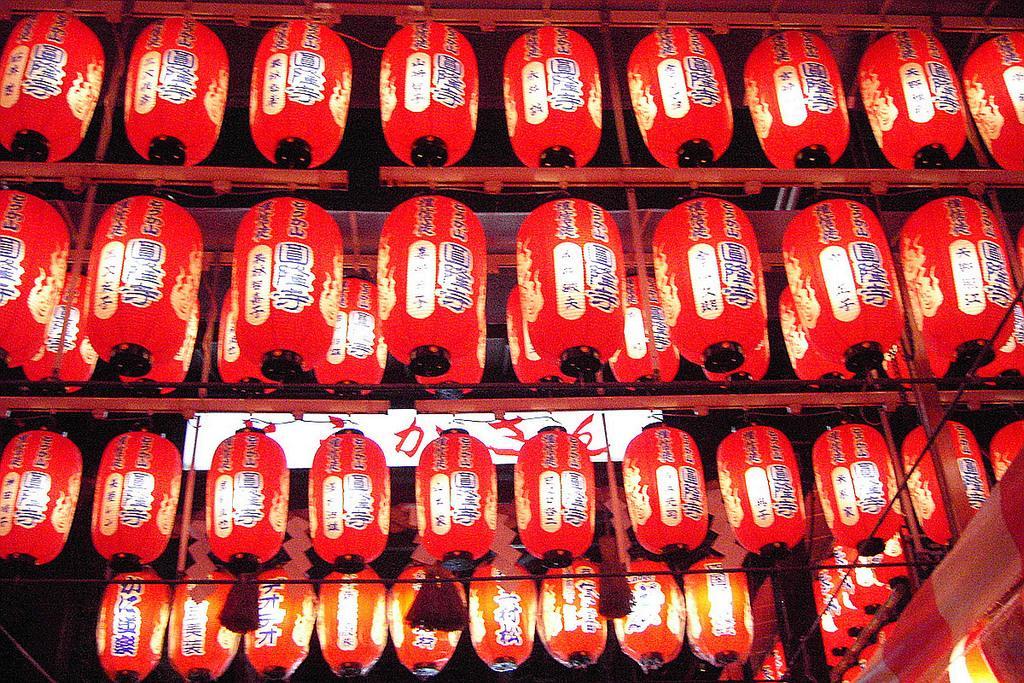Could you give a brief overview of what you see in this image? In this image I see number of Chinese lanterns and I see words written on it and I see they're of red in color. 